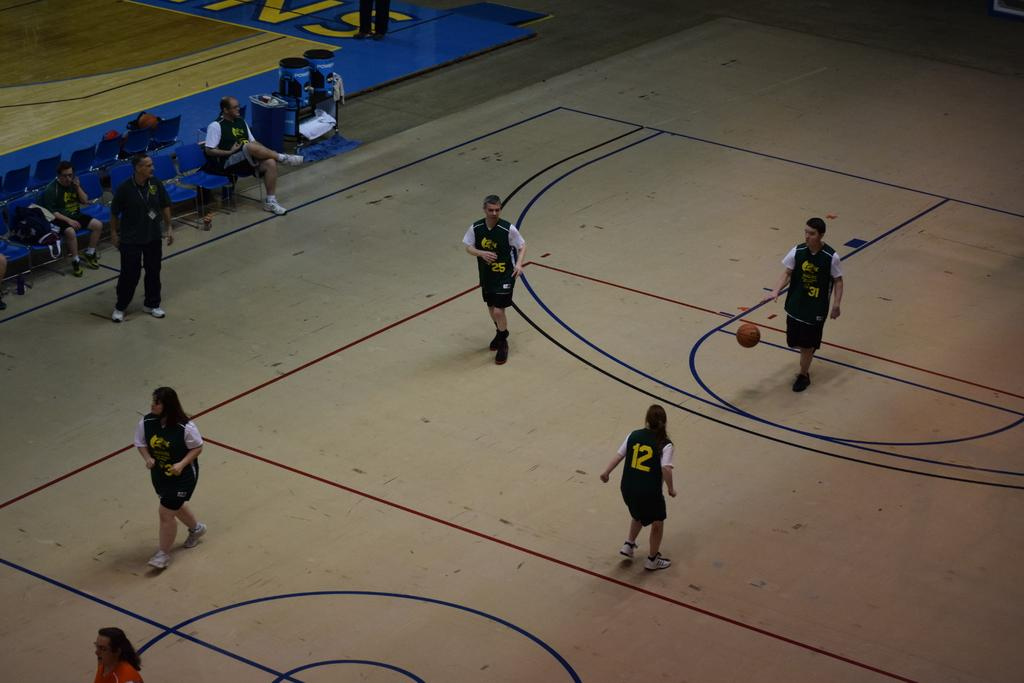<image>
Describe the image concisely. a player has the number 12 on the back of their jersey 